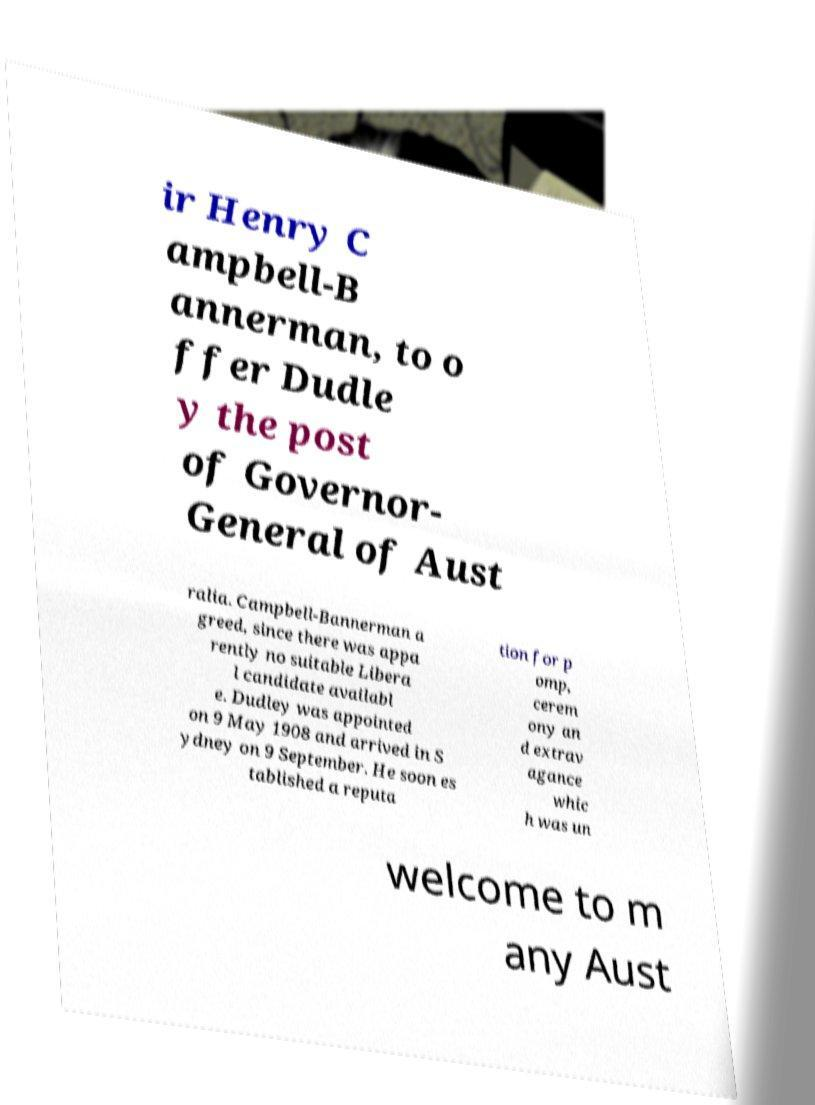Can you read and provide the text displayed in the image?This photo seems to have some interesting text. Can you extract and type it out for me? ir Henry C ampbell-B annerman, to o ffer Dudle y the post of Governor- General of Aust ralia. Campbell-Bannerman a greed, since there was appa rently no suitable Libera l candidate availabl e. Dudley was appointed on 9 May 1908 and arrived in S ydney on 9 September. He soon es tablished a reputa tion for p omp, cerem ony an d extrav agance whic h was un welcome to m any Aust 